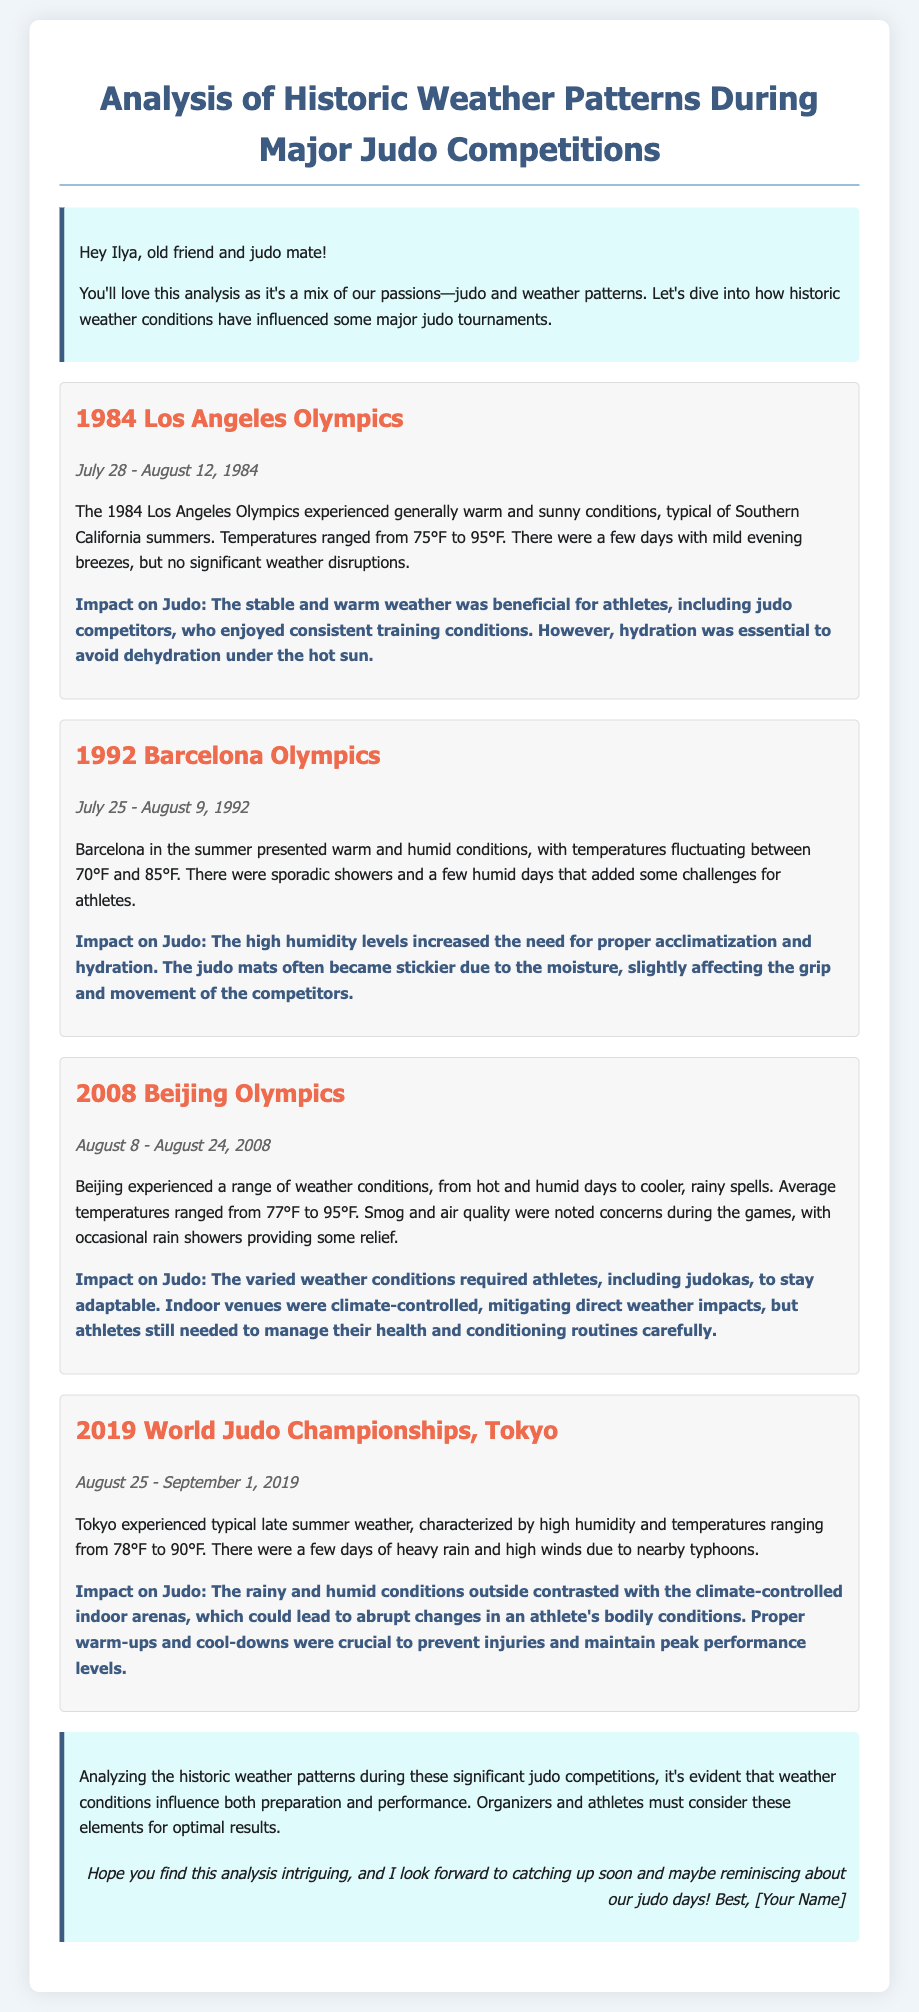What is the main focus of the analysis? The analysis focuses on how historic weather conditions have influenced major judo tournaments.
Answer: Historic weather patterns During which event did athletes face temperatures ranging from 75°F to 95°F? This temperature range was experienced during the 1984 Los Angeles Olympics.
Answer: 1984 Los Angeles Olympics What type of weather was reported during the 1992 Barcelona Olympics? The document states warm and humid conditions with sporadic showers were reported.
Answer: Warm and humid conditions What was a major concern during the 2008 Beijing Olympics? The document notes that smog and air quality were major concerns during the games.
Answer: Smog and air quality How did the weather impact competitors during the 2019 World Judo Championships? The rainy and humid conditions outside contrasted with climate-controlled indoor arenas impacting athletes' conditions.
Answer: Contrasted climate conditions What was the date range for the 2019 World Judo Championships? The date range for this event is August 25 to September 1, 2019.
Answer: August 25 - September 1, 2019 Which year did the Los Angeles Olympics take place? The Los Angeles Olympics took place in 1984.
Answer: 1984 What was the impact of humidity during the 1992 Barcelona Olympics? The high humidity levels increased the need for proper acclimatization and hydration for the athletes.
Answer: Increased need for hydration What conclusion is drawn from the analysis? The conclusion highlights that weather conditions influence both preparation and performance in judo competitions.
Answer: Weather influences preparation and performance 